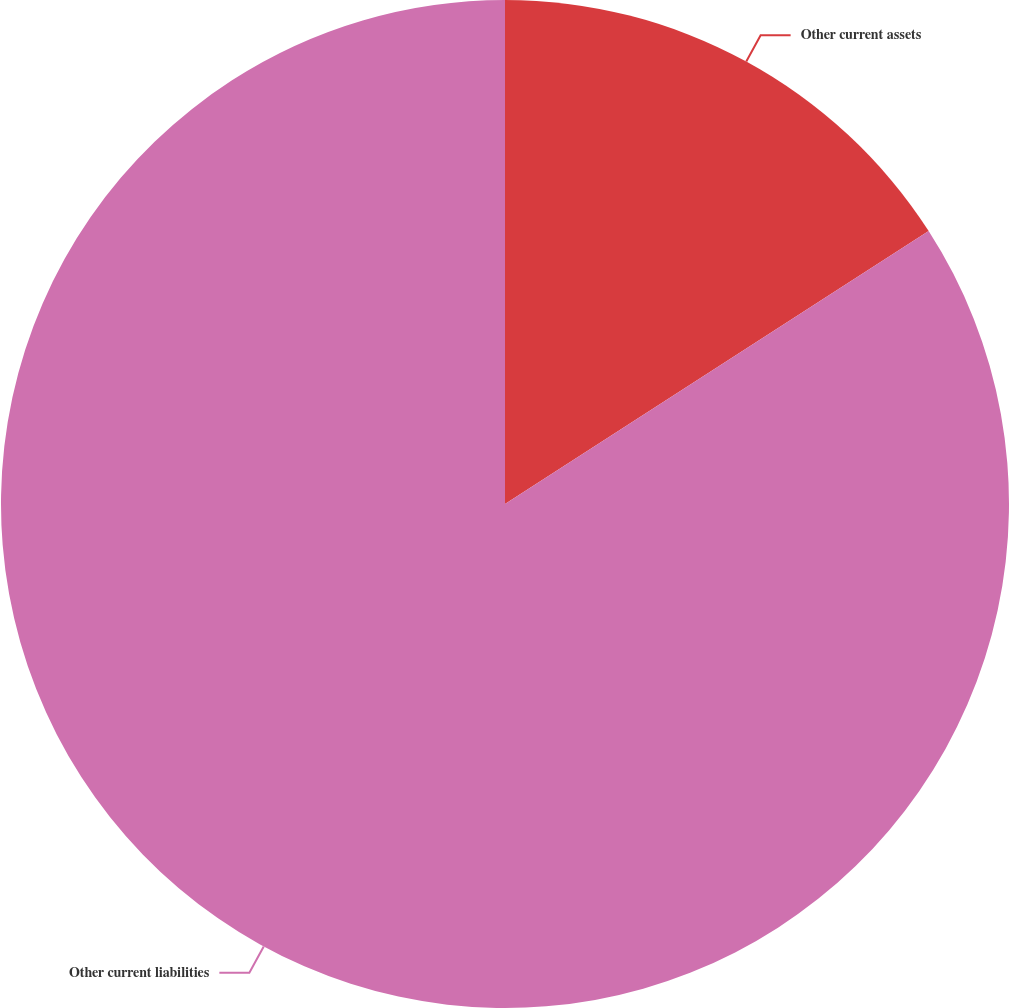<chart> <loc_0><loc_0><loc_500><loc_500><pie_chart><fcel>Other current assets<fcel>Other current liabilities<nl><fcel>15.89%<fcel>84.11%<nl></chart> 